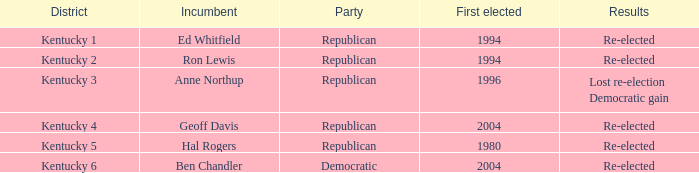What year marked the initial election of the republican incumbent representing kentucky's 2nd district? 1994.0. 